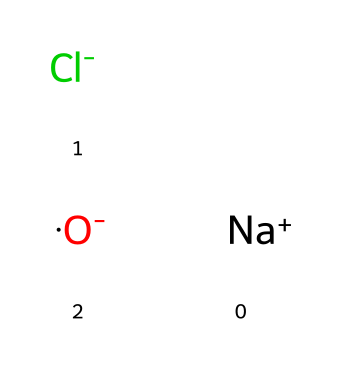What is the chemical formula represented by this SMILES? The SMILES notation breaks down to three components: sodium (Na+), chloride (Cl-), and a negatively charged oxygen (O-), indicating that the overall formula corresponds to NaClO, which is sodium hypochlorite.
Answer: sodium hypochlorite How many atoms are present in this chemical? Counting the distinct atoms in the SMILES, we find one sodium atom, one chlorine atom, and one oxygen atom. Therefore, the total number of atoms is three.
Answer: three What is the charge of the sodium ion in this compound? The SMILES notation shows "Na+" which indicates that the sodium ion carries a positive charge.
Answer: positive What type of bond is likely present between the sodium ion and chloride ion? The sodium ion (Na+) and chloride ion (Cl-) carry opposite charges, which typically leads to the formation of an ionic bond due to electrostatic attraction.
Answer: ionic bond Which part of the molecule contains the disinfecting properties? The presence of the chlorine atom (Cl-) in the structure is responsible for the disinfecting properties, as chlorine is well-known for its antimicrobial action.
Answer: chlorine What implication does the presence of oxygen in the chemical have? The negatively charged oxygen (O-) indicates that this compound can act as an oxidizing agent, which enhances its disinfectant qualities by breaking down organic material and microorganisms.
Answer: oxidizing agent Why is sodium hypochlorite commonly used in textile preservation? Sodium hypochlorite acts as a potent bleach and disinfectant, effectively eliminating bacteria and preventing decay of organic materials, thus preserving antique textiles.
Answer: potent bleach and disinfectant 